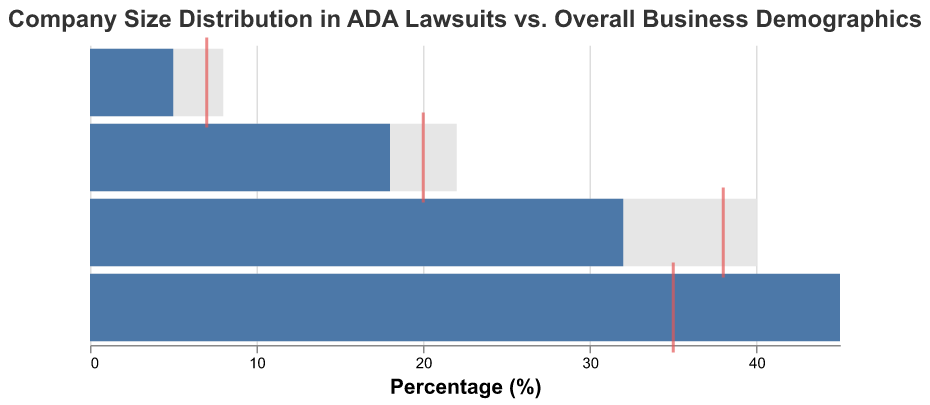What is the title of the figure? The title of the figure is prominently displayed at the top.
Answer: Company Size Distribution in ADA Lawsuits vs. Overall Business Demographics What is the percentage of Small Businesses in ADA lawsuits? The figure shows the percentage of Small Businesses in ADA lawsuits with the bar marked in blue.
Answer: 45% How do Medium Businesses compare in actual versus target percentages in ADA lawsuits? Compare the blue bar for the actual percentage and the red tick mark for the target percentage.
Answer: 32% (actual) vs. 38% (target) Which company size category has the least representation in ADA lawsuits, and what is the percentage? Look at the blue bar segments to identify which is the smallest.
Answer: Enterprise (5%) How does the distribution of Large Businesses in ADA lawsuits compare to their overall business demographics? Compare the blue bar (ADA lawsuit percentage) and the grey bar (overall business demographics percentage) for Large Businesses.
Answer: 18% (ADA lawsuits) vs. 22% (overall business demographics) What is the difference between the comparative percentage and the actual percentage for Small Businesses? Subtract the actual percentage from the comparative percentage for Small Businesses.
Answer: 15% (45% actual - 30% comparative) What is the target value of lawsuits for Enterprise companies? Look for the red tick mark on the Enterprise category.
Answer: 7% Which company size category exceeds their target percentage the most in ADA lawsuits? Compare the differences between actual and target percentages for each category.
Answer: Small Businesses (10% over target; 45% actual vs. 35% target) Are Medium Businesses over or underrepresented in ADA lawsuits compared to their overall business demographics? Compare the actual percentages (blue bar) with the comparative percentages (grey bar) for Medium Businesses.
Answer: Underrepresented (32% actual vs. 40% comparative) What is the combined actual percentage of ADA lawsuits for Large Businesses and Enterprise categories? Add the actual percentages for Large Businesses and Enterprise (18% + 5%).
Answer: 23% 